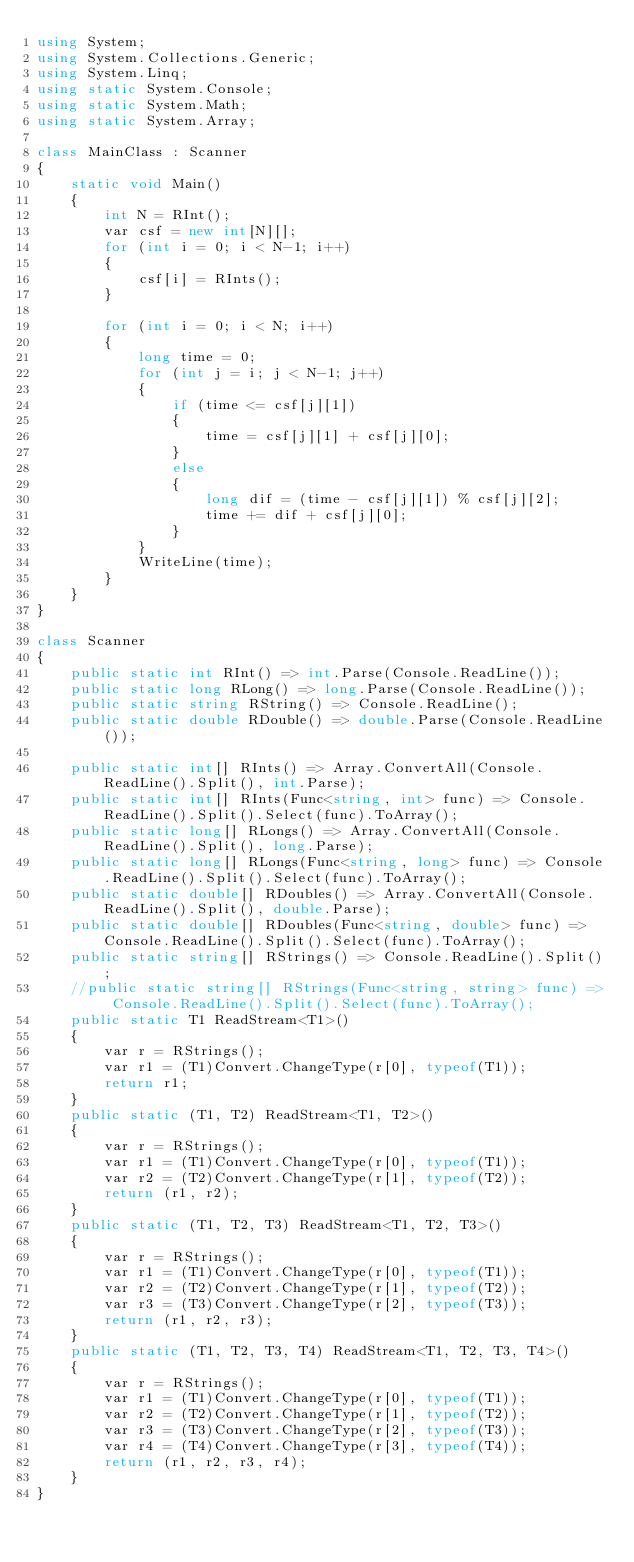<code> <loc_0><loc_0><loc_500><loc_500><_C#_>using System;
using System.Collections.Generic;
using System.Linq;
using static System.Console;
using static System.Math;
using static System.Array;

class MainClass : Scanner
{
    static void Main()
    {
        int N = RInt();
        var csf = new int[N][];
        for (int i = 0; i < N-1; i++)
        {
            csf[i] = RInts();
        }

        for (int i = 0; i < N; i++)
        {
            long time = 0;
            for (int j = i; j < N-1; j++)
            {
                if (time <= csf[j][1])
                {
                    time = csf[j][1] + csf[j][0];
                }
                else
                {
                    long dif = (time - csf[j][1]) % csf[j][2];
                    time += dif + csf[j][0];
                }
            }
            WriteLine(time);
        }
    }
}

class Scanner
{
    public static int RInt() => int.Parse(Console.ReadLine());
    public static long RLong() => long.Parse(Console.ReadLine());
    public static string RString() => Console.ReadLine();
    public static double RDouble() => double.Parse(Console.ReadLine());

    public static int[] RInts() => Array.ConvertAll(Console.ReadLine().Split(), int.Parse);
    public static int[] RInts(Func<string, int> func) => Console.ReadLine().Split().Select(func).ToArray();
    public static long[] RLongs() => Array.ConvertAll(Console.ReadLine().Split(), long.Parse);
    public static long[] RLongs(Func<string, long> func) => Console.ReadLine().Split().Select(func).ToArray();
    public static double[] RDoubles() => Array.ConvertAll(Console.ReadLine().Split(), double.Parse);
    public static double[] RDoubles(Func<string, double> func) => Console.ReadLine().Split().Select(func).ToArray();
    public static string[] RStrings() => Console.ReadLine().Split();
    //public static string[] RStrings(Func<string, string> func) => Console.ReadLine().Split().Select(func).ToArray();
    public static T1 ReadStream<T1>()
    {
        var r = RStrings();
        var r1 = (T1)Convert.ChangeType(r[0], typeof(T1));
        return r1;
    }
    public static (T1, T2) ReadStream<T1, T2>()
    {
        var r = RStrings();
        var r1 = (T1)Convert.ChangeType(r[0], typeof(T1));
        var r2 = (T2)Convert.ChangeType(r[1], typeof(T2));
        return (r1, r2);
    }
    public static (T1, T2, T3) ReadStream<T1, T2, T3>()
    {
        var r = RStrings();
        var r1 = (T1)Convert.ChangeType(r[0], typeof(T1));
        var r2 = (T2)Convert.ChangeType(r[1], typeof(T2));
        var r3 = (T3)Convert.ChangeType(r[2], typeof(T3));
        return (r1, r2, r3);
    }
    public static (T1, T2, T3, T4) ReadStream<T1, T2, T3, T4>()
    {
        var r = RStrings();
        var r1 = (T1)Convert.ChangeType(r[0], typeof(T1));
        var r2 = (T2)Convert.ChangeType(r[1], typeof(T2));
        var r3 = (T3)Convert.ChangeType(r[2], typeof(T3));
        var r4 = (T4)Convert.ChangeType(r[3], typeof(T4));
        return (r1, r2, r3, r4);
    }
}</code> 